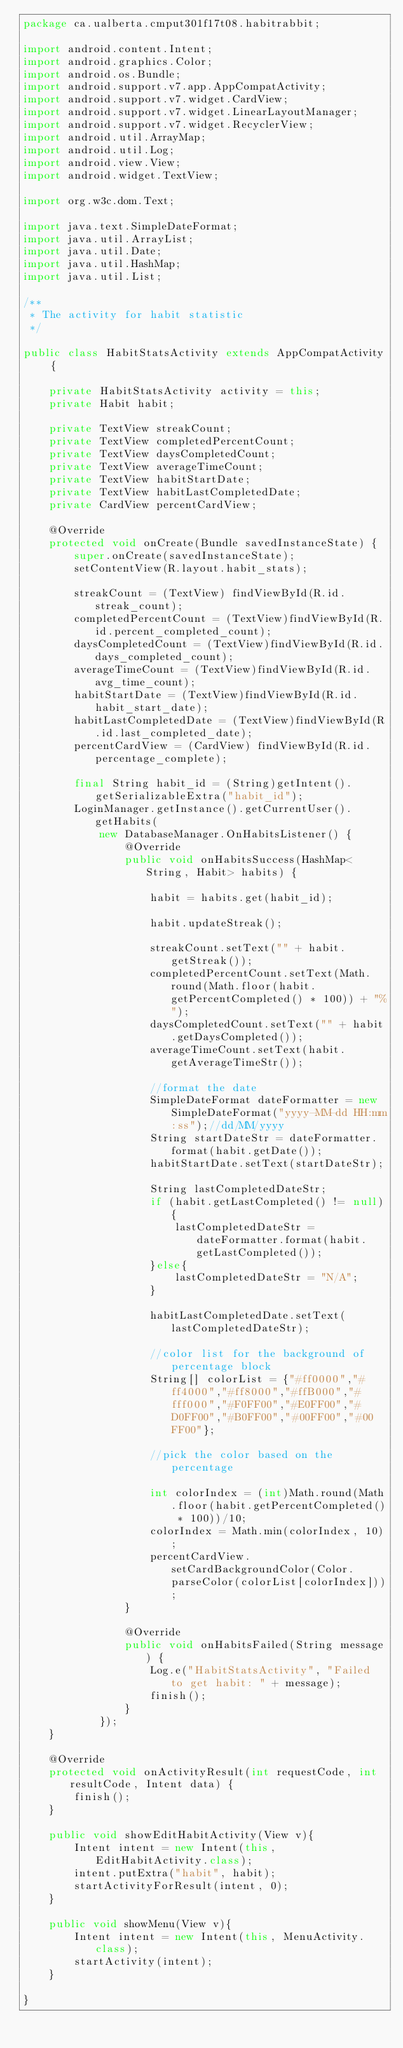<code> <loc_0><loc_0><loc_500><loc_500><_Java_>package ca.ualberta.cmput301f17t08.habitrabbit;

import android.content.Intent;
import android.graphics.Color;
import android.os.Bundle;
import android.support.v7.app.AppCompatActivity;
import android.support.v7.widget.CardView;
import android.support.v7.widget.LinearLayoutManager;
import android.support.v7.widget.RecyclerView;
import android.util.ArrayMap;
import android.util.Log;
import android.view.View;
import android.widget.TextView;

import org.w3c.dom.Text;

import java.text.SimpleDateFormat;
import java.util.ArrayList;
import java.util.Date;
import java.util.HashMap;
import java.util.List;

/**
 * The activity for habit statistic
 */

public class HabitStatsActivity extends AppCompatActivity {

    private HabitStatsActivity activity = this;
    private Habit habit;

    private TextView streakCount;
    private TextView completedPercentCount;
    private TextView daysCompletedCount;
    private TextView averageTimeCount;
    private TextView habitStartDate;
    private TextView habitLastCompletedDate;
    private CardView percentCardView;

    @Override
    protected void onCreate(Bundle savedInstanceState) {
        super.onCreate(savedInstanceState);
        setContentView(R.layout.habit_stats);

        streakCount = (TextView) findViewById(R.id.streak_count);
        completedPercentCount = (TextView)findViewById(R.id.percent_completed_count);
        daysCompletedCount = (TextView)findViewById(R.id.days_completed_count);
        averageTimeCount = (TextView)findViewById(R.id.avg_time_count);
        habitStartDate = (TextView)findViewById(R.id.habit_start_date);
        habitLastCompletedDate = (TextView)findViewById(R.id.last_completed_date);
        percentCardView = (CardView) findViewById(R.id.percentage_complete);

        final String habit_id = (String)getIntent().getSerializableExtra("habit_id");
        LoginManager.getInstance().getCurrentUser().getHabits(
            new DatabaseManager.OnHabitsListener() {
                @Override
                public void onHabitsSuccess(HashMap<String, Habit> habits) {

                    habit = habits.get(habit_id);

                    habit.updateStreak();

                    streakCount.setText("" + habit.getStreak());
                    completedPercentCount.setText(Math.round(Math.floor(habit.getPercentCompleted() * 100)) + "%");
                    daysCompletedCount.setText("" + habit.getDaysCompleted());
                    averageTimeCount.setText(habit.getAverageTimeStr());

                    //format the date
                    SimpleDateFormat dateFormatter = new SimpleDateFormat("yyyy-MM-dd HH:mm:ss");//dd/MM/yyyy
                    String startDateStr = dateFormatter.format(habit.getDate());
                    habitStartDate.setText(startDateStr);

                    String lastCompletedDateStr;
                    if (habit.getLastCompleted() != null){
                        lastCompletedDateStr = dateFormatter.format(habit.getLastCompleted());
                    }else{
                        lastCompletedDateStr = "N/A";
                    }

                    habitLastCompletedDate.setText(lastCompletedDateStr);

                    //color list for the background of percentage block
                    String[] colorList = {"#ff0000","#ff4000","#ff8000","#ffB000","#fff000","#F0FF00","#E0FF00","#D0FF00","#B0FF00","#00FF00","#00FF00"};

                    //pick the color based on the percentage

                    int colorIndex = (int)Math.round(Math.floor(habit.getPercentCompleted() * 100))/10;
                    colorIndex = Math.min(colorIndex, 10);
                    percentCardView.setCardBackgroundColor(Color.parseColor(colorList[colorIndex]));
                }

                @Override
                public void onHabitsFailed(String message) {
                    Log.e("HabitStatsActivity", "Failed to get habit: " + message);
                    finish();
                }
            });
    }

    @Override
    protected void onActivityResult(int requestCode, int resultCode, Intent data) {
        finish();
    }

    public void showEditHabitActivity(View v){
        Intent intent = new Intent(this, EditHabitActivity.class);
        intent.putExtra("habit", habit);
        startActivityForResult(intent, 0);
    }

    public void showMenu(View v){
        Intent intent = new Intent(this, MenuActivity.class);
        startActivity(intent);
    }

}
</code> 